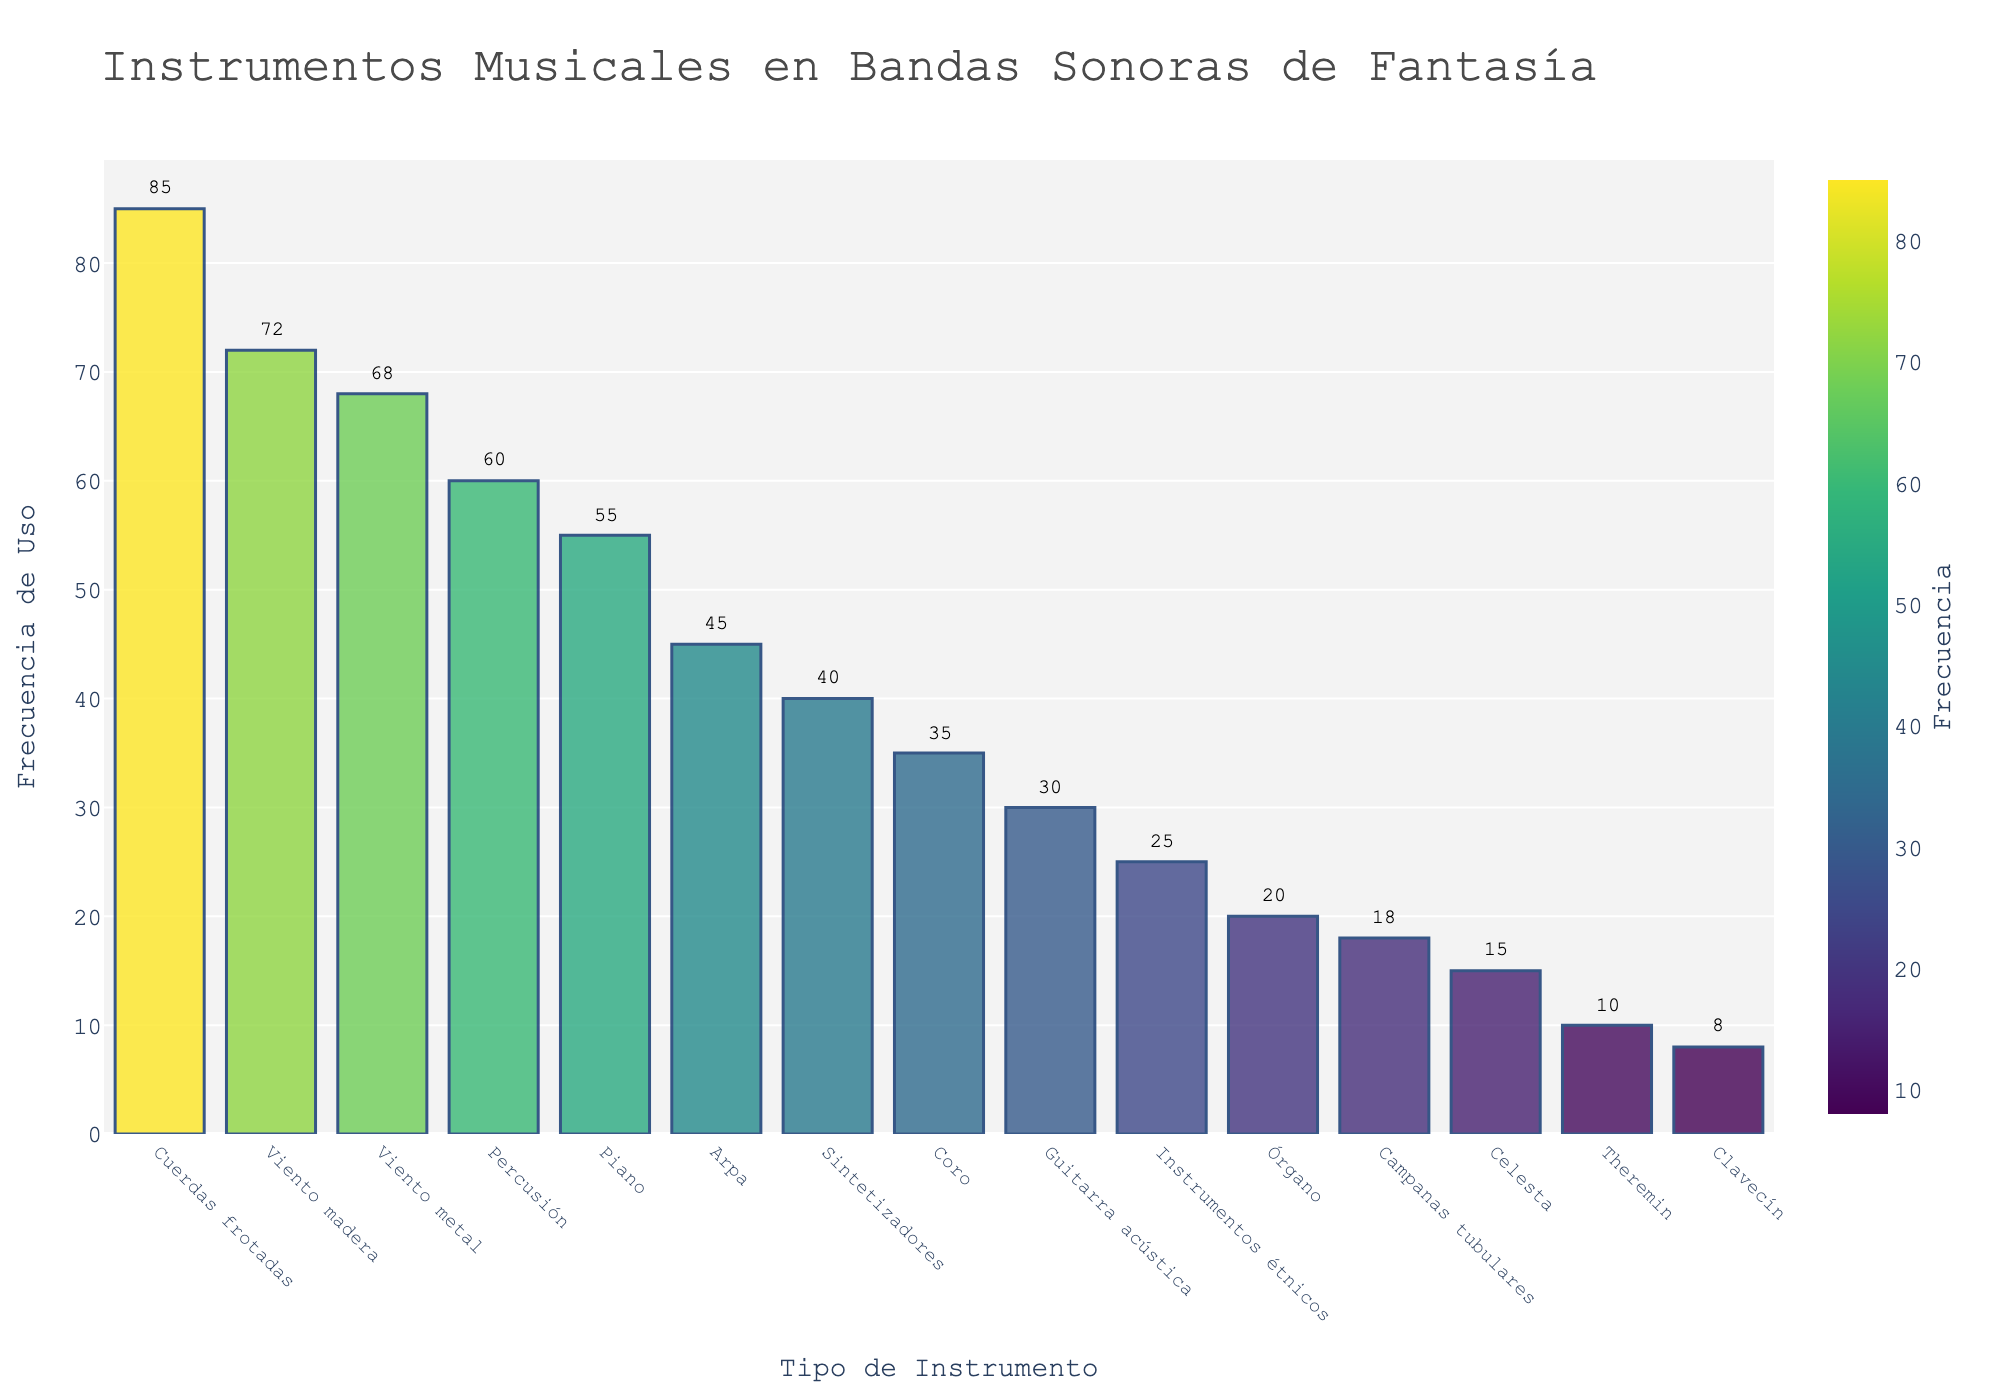¿Cuál es el instrumento musical más utilizado en bandas sonoras de películas de fantasía? Al observar la altura de las barras en el gráfico, podemos ver que la barra más alta pertenece a 'Cuerdas frotadas'. Esto indica que es el instrumento más utilizado con una frecuencia de 85.
Answer: Cuerdas frotadas ¿Cuántos más veces se utiliza el piano en comparación con el theremin? La frecuencia de uso del piano es 55 y la del theremin es 10. La diferencia entre ambos es 55 - 10 = 45.
Answer: 45 ¿Qué instrumento tiene una frecuencia de uso igual a 20? En el gráfico, la barra que corresponde a una frecuencia de 20 pertenece al 'Órgano'.
Answer: Órgano ¿Cuál es el promedio de uso de los primeros tres instrumentos más utilizados? Los primeros tres instrumentos más utilizados son 'Cuerdas frotadas' (85), 'Viento madera' (72) y 'Viento metal' (68). Sumamos sus frecuencias 85 + 72 + 68 = 225 y dividimos por 3 para obtener el promedio 225 / 3 = 75.
Answer: 75 ¿Cuántos instrumentos tienen una frecuencia de uso menor que 20? Observando el gráfico, podemos ver que las barras de 'Campanas tubulares' (18), 'Celesta' (15), 'Theremin' (10) y 'Clavecín' (8) están por debajo de 20. Contamos estos instrumentos y obtenemos 4.
Answer: 4 ¿Cuál es la diferencia de uso entre el instrumento más utilizado y el menos utilizado? El instrumento más utilizado es 'Cuerdas frotadas' con una frecuencia de 85 y el menos utilizado es 'Clavecín' con una frecuencia de 8. La diferencia es 85 - 8 = 77.
Answer: 77 ¿Cuántos instrumentos tienen una frecuencia de uso entre 30 y 60? Observando las barras que indican frecuencias de uso entre 30 y 60, encontramos que 'Percusión' (60), 'Piano' (55), 'Arpa' (45), 'Sintetizadores' (40), 'Coro' (35) y 'Guitarra acústica' (30) cumplen con esta condición. Contamos estos instrumentos y hay 6.
Answer: 6 ¿Cuál es la suma de las frecuencias de uso de 'Viento madera' y 'Percusión'? Las frecuencias de uso de 'Viento madera' y 'Percusión' son 72 y 60, respectivamente. Sumamos estas frecuencias: 72 + 60 = 132.
Answer: 132 ¿Qué instrumento tiene una menor frecuencia de uso que el órgano pero mayor que el theremin? Observando las barras, podemos ver que 'Campanas tubulares' tiene una frecuencia de uso de 18, que es menor que 20 (Órgano) y mayor que 10 (Theremin).
Answer: Campanas tubulares 